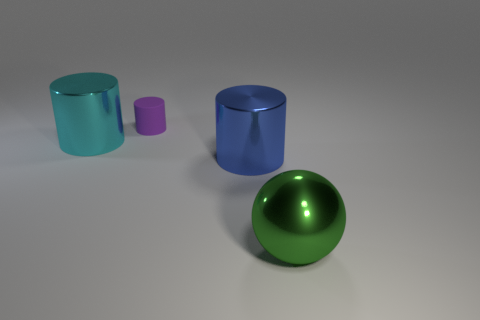Add 4 cyan cylinders. How many objects exist? 8 Subtract all large metallic cylinders. How many cylinders are left? 1 Subtract all blue cylinders. How many cylinders are left? 2 Subtract 1 cylinders. How many cylinders are left? 2 Subtract all cylinders. How many objects are left? 1 Subtract all cyan cylinders. Subtract all brown blocks. How many cylinders are left? 2 Subtract all large blue objects. Subtract all large shiny cylinders. How many objects are left? 1 Add 4 big cyan metallic objects. How many big cyan metallic objects are left? 5 Add 2 blue shiny objects. How many blue shiny objects exist? 3 Subtract 0 red balls. How many objects are left? 4 